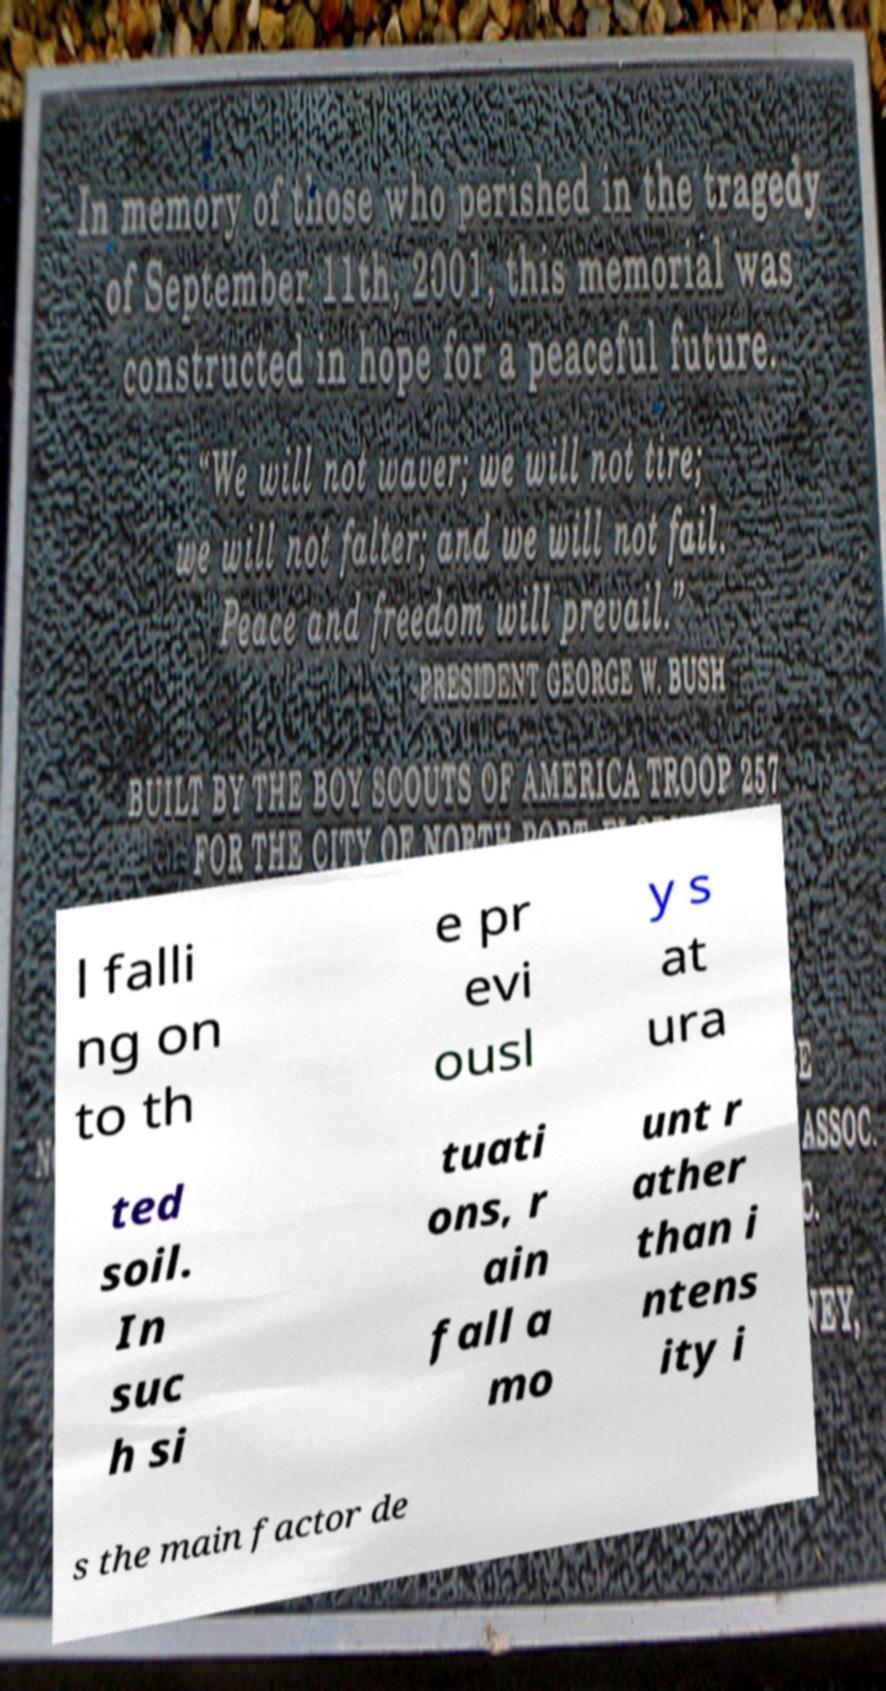For documentation purposes, I need the text within this image transcribed. Could you provide that? l falli ng on to th e pr evi ousl y s at ura ted soil. In suc h si tuati ons, r ain fall a mo unt r ather than i ntens ity i s the main factor de 